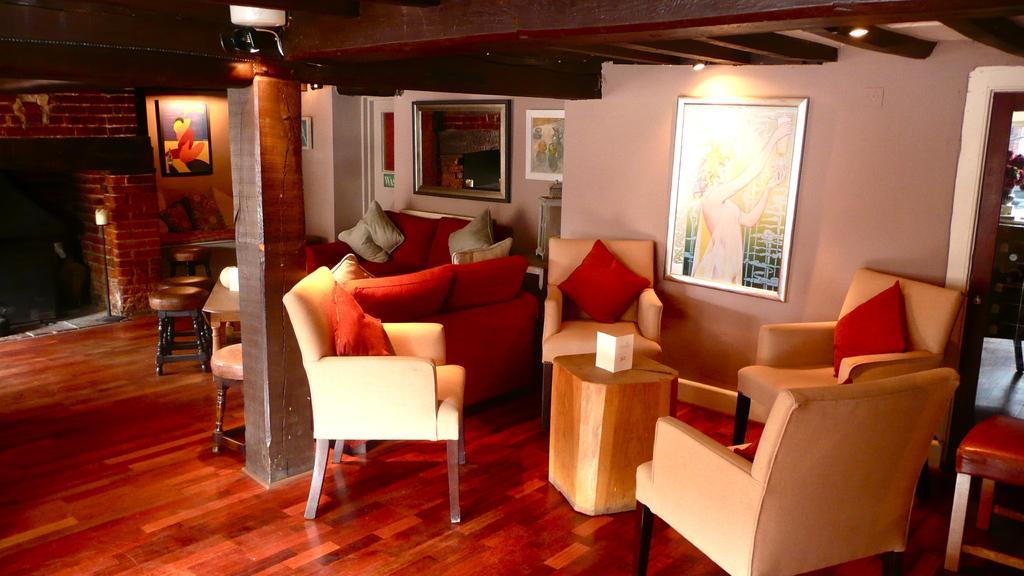Describe this image in one or two sentences. These are the sofa chairs, on the right side there is an image frame on the wall. 